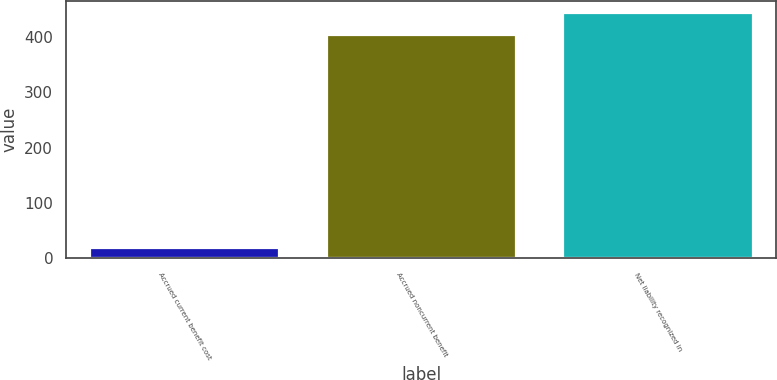<chart> <loc_0><loc_0><loc_500><loc_500><bar_chart><fcel>Accrued current benefit cost<fcel>Accrued noncurrent benefit<fcel>Net liability recognized in<nl><fcel>17.7<fcel>402.3<fcel>442.53<nl></chart> 